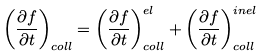Convert formula to latex. <formula><loc_0><loc_0><loc_500><loc_500>\left ( \frac { \partial f } { \partial t } \right ) _ { c o l l } = \left ( \frac { \partial f } { \partial t } \right ) _ { c o l l } ^ { e l } + \left ( \frac { \partial f } { \partial t } \right ) _ { c o l l } ^ { i n e l }</formula> 